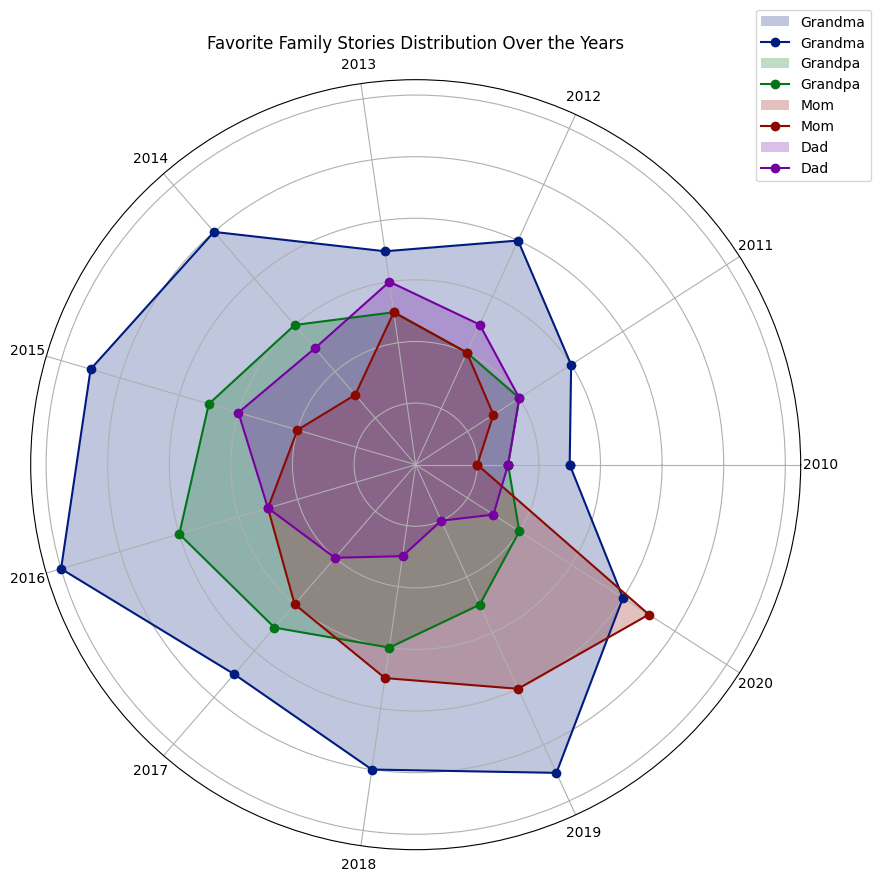Which family member told the most stories in 2015? Looking at the data points on the chart, we count the number of stories for each family member in 2015. Grandma told 11 stories, Grandpa 7 stories, Mom 4 stories, and Dad 6 stories, so Grandma told the most stories.
Answer: Grandma How many more stories did Grandpa tell in 2016 compared to 2012? We find the number of stories Grandpa told in 2016 and 2012. In 2016, it was 8 stories, and in 2012, it was 4 stories. The difference is 8 - 4 = 4 stories.
Answer: 4 Who had the highest increase in the number of stories told from 2010 to 2020? To find this, we calculate the difference across the years for each family member. For Grandma, it is 8-5=3; Grandpa, 4-3=1; Mom, 9-2=7; Dad, 3-3=0. Mom had the highest increase of 7 stories.
Answer: Mom In which year was the total number of stories told by Grandma and Grandpa the same? We compare each year to find when the number of stories told by Grandma and Grandpa adds up to the same value. In 2017, Grandma told 9 stories and Grandpa also told 7 stories. Adding them up, we find they total differently in other years.
Answer: None Which periods show a decline in the number of stories told for both Mom and Dad? To determine the periods of decline, we examine year-over-year changes. Mom's stories increased each year, showing no decline. For Dad, there are declines in two periods: from 2017 (4 stories) to 2018 (3 stories), and from 2018 (3 stories) to 2019 (2 stories). Both do not overlap simultaneously.
Answer: None 